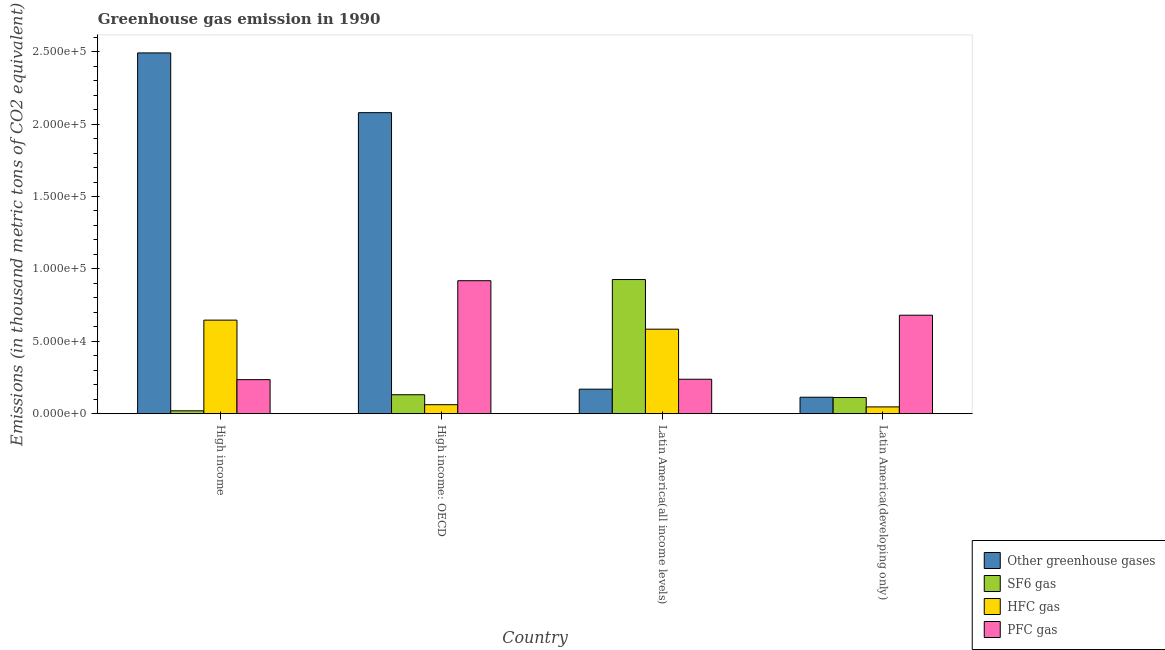How many different coloured bars are there?
Ensure brevity in your answer.  4. How many groups of bars are there?
Provide a succinct answer. 4. Are the number of bars on each tick of the X-axis equal?
Your response must be concise. Yes. How many bars are there on the 2nd tick from the left?
Your answer should be compact. 4. How many bars are there on the 1st tick from the right?
Offer a terse response. 4. What is the label of the 2nd group of bars from the left?
Ensure brevity in your answer.  High income: OECD. What is the emission of sf6 gas in Latin America(developing only)?
Your answer should be very brief. 1.12e+04. Across all countries, what is the maximum emission of hfc gas?
Give a very brief answer. 6.46e+04. Across all countries, what is the minimum emission of pfc gas?
Ensure brevity in your answer.  2.35e+04. In which country was the emission of hfc gas minimum?
Provide a succinct answer. Latin America(developing only). What is the total emission of sf6 gas in the graph?
Your answer should be very brief. 1.19e+05. What is the difference between the emission of hfc gas in High income and that in Latin America(all income levels)?
Your answer should be very brief. 6246.3. What is the difference between the emission of pfc gas in Latin America(all income levels) and the emission of sf6 gas in Latin America(developing only)?
Make the answer very short. 1.26e+04. What is the average emission of greenhouse gases per country?
Your response must be concise. 1.21e+05. What is the difference between the emission of hfc gas and emission of sf6 gas in Latin America(developing only)?
Your response must be concise. -6470.2. In how many countries, is the emission of hfc gas greater than 30000 thousand metric tons?
Make the answer very short. 2. What is the ratio of the emission of sf6 gas in Latin America(all income levels) to that in Latin America(developing only)?
Give a very brief answer. 8.28. Is the emission of greenhouse gases in High income less than that in Latin America(developing only)?
Give a very brief answer. No. What is the difference between the highest and the second highest emission of pfc gas?
Offer a very short reply. 2.38e+04. What is the difference between the highest and the lowest emission of sf6 gas?
Provide a short and direct response. 9.06e+04. Is the sum of the emission of pfc gas in Latin America(all income levels) and Latin America(developing only) greater than the maximum emission of hfc gas across all countries?
Make the answer very short. Yes. What does the 3rd bar from the left in High income: OECD represents?
Provide a short and direct response. HFC gas. What does the 2nd bar from the right in Latin America(developing only) represents?
Your response must be concise. HFC gas. Is it the case that in every country, the sum of the emission of greenhouse gases and emission of sf6 gas is greater than the emission of hfc gas?
Make the answer very short. Yes. Are all the bars in the graph horizontal?
Provide a succinct answer. No. How many countries are there in the graph?
Give a very brief answer. 4. Are the values on the major ticks of Y-axis written in scientific E-notation?
Keep it short and to the point. Yes. Does the graph contain any zero values?
Give a very brief answer. No. Where does the legend appear in the graph?
Your response must be concise. Bottom right. How many legend labels are there?
Offer a very short reply. 4. How are the legend labels stacked?
Keep it short and to the point. Vertical. What is the title of the graph?
Your answer should be very brief. Greenhouse gas emission in 1990. Does "Environmental sustainability" appear as one of the legend labels in the graph?
Offer a terse response. No. What is the label or title of the X-axis?
Provide a short and direct response. Country. What is the label or title of the Y-axis?
Provide a short and direct response. Emissions (in thousand metric tons of CO2 equivalent). What is the Emissions (in thousand metric tons of CO2 equivalent) of Other greenhouse gases in High income?
Provide a succinct answer. 2.49e+05. What is the Emissions (in thousand metric tons of CO2 equivalent) in SF6 gas in High income?
Offer a very short reply. 2028.7. What is the Emissions (in thousand metric tons of CO2 equivalent) in HFC gas in High income?
Make the answer very short. 6.46e+04. What is the Emissions (in thousand metric tons of CO2 equivalent) in PFC gas in High income?
Make the answer very short. 2.35e+04. What is the Emissions (in thousand metric tons of CO2 equivalent) of Other greenhouse gases in High income: OECD?
Ensure brevity in your answer.  2.08e+05. What is the Emissions (in thousand metric tons of CO2 equivalent) in SF6 gas in High income: OECD?
Provide a short and direct response. 1.31e+04. What is the Emissions (in thousand metric tons of CO2 equivalent) in HFC gas in High income: OECD?
Keep it short and to the point. 6246.3. What is the Emissions (in thousand metric tons of CO2 equivalent) of PFC gas in High income: OECD?
Your answer should be very brief. 9.19e+04. What is the Emissions (in thousand metric tons of CO2 equivalent) of Other greenhouse gases in Latin America(all income levels)?
Your answer should be compact. 1.70e+04. What is the Emissions (in thousand metric tons of CO2 equivalent) in SF6 gas in Latin America(all income levels)?
Offer a very short reply. 9.27e+04. What is the Emissions (in thousand metric tons of CO2 equivalent) of HFC gas in Latin America(all income levels)?
Offer a terse response. 5.84e+04. What is the Emissions (in thousand metric tons of CO2 equivalent) in PFC gas in Latin America(all income levels)?
Provide a succinct answer. 2.38e+04. What is the Emissions (in thousand metric tons of CO2 equivalent) in Other greenhouse gases in Latin America(developing only)?
Ensure brevity in your answer.  1.14e+04. What is the Emissions (in thousand metric tons of CO2 equivalent) in SF6 gas in Latin America(developing only)?
Provide a short and direct response. 1.12e+04. What is the Emissions (in thousand metric tons of CO2 equivalent) in HFC gas in Latin America(developing only)?
Give a very brief answer. 4722. What is the Emissions (in thousand metric tons of CO2 equivalent) of PFC gas in Latin America(developing only)?
Make the answer very short. 6.80e+04. Across all countries, what is the maximum Emissions (in thousand metric tons of CO2 equivalent) of Other greenhouse gases?
Offer a very short reply. 2.49e+05. Across all countries, what is the maximum Emissions (in thousand metric tons of CO2 equivalent) of SF6 gas?
Offer a very short reply. 9.27e+04. Across all countries, what is the maximum Emissions (in thousand metric tons of CO2 equivalent) of HFC gas?
Provide a short and direct response. 6.46e+04. Across all countries, what is the maximum Emissions (in thousand metric tons of CO2 equivalent) in PFC gas?
Your answer should be very brief. 9.19e+04. Across all countries, what is the minimum Emissions (in thousand metric tons of CO2 equivalent) in Other greenhouse gases?
Your answer should be very brief. 1.14e+04. Across all countries, what is the minimum Emissions (in thousand metric tons of CO2 equivalent) in SF6 gas?
Make the answer very short. 2028.7. Across all countries, what is the minimum Emissions (in thousand metric tons of CO2 equivalent) of HFC gas?
Make the answer very short. 4722. Across all countries, what is the minimum Emissions (in thousand metric tons of CO2 equivalent) of PFC gas?
Your answer should be compact. 2.35e+04. What is the total Emissions (in thousand metric tons of CO2 equivalent) of Other greenhouse gases in the graph?
Your answer should be compact. 4.85e+05. What is the total Emissions (in thousand metric tons of CO2 equivalent) in SF6 gas in the graph?
Offer a terse response. 1.19e+05. What is the total Emissions (in thousand metric tons of CO2 equivalent) in HFC gas in the graph?
Offer a terse response. 1.34e+05. What is the total Emissions (in thousand metric tons of CO2 equivalent) of PFC gas in the graph?
Your answer should be very brief. 2.07e+05. What is the difference between the Emissions (in thousand metric tons of CO2 equivalent) in Other greenhouse gases in High income and that in High income: OECD?
Your answer should be very brief. 4.13e+04. What is the difference between the Emissions (in thousand metric tons of CO2 equivalent) in SF6 gas in High income and that in High income: OECD?
Make the answer very short. -1.11e+04. What is the difference between the Emissions (in thousand metric tons of CO2 equivalent) in HFC gas in High income and that in High income: OECD?
Your response must be concise. 5.84e+04. What is the difference between the Emissions (in thousand metric tons of CO2 equivalent) of PFC gas in High income and that in High income: OECD?
Offer a very short reply. -6.83e+04. What is the difference between the Emissions (in thousand metric tons of CO2 equivalent) in Other greenhouse gases in High income and that in Latin America(all income levels)?
Provide a succinct answer. 2.32e+05. What is the difference between the Emissions (in thousand metric tons of CO2 equivalent) of SF6 gas in High income and that in Latin America(all income levels)?
Provide a succinct answer. -9.06e+04. What is the difference between the Emissions (in thousand metric tons of CO2 equivalent) of HFC gas in High income and that in Latin America(all income levels)?
Offer a very short reply. 6246.3. What is the difference between the Emissions (in thousand metric tons of CO2 equivalent) in PFC gas in High income and that in Latin America(all income levels)?
Your answer should be compact. -283.1. What is the difference between the Emissions (in thousand metric tons of CO2 equivalent) in Other greenhouse gases in High income and that in Latin America(developing only)?
Offer a very short reply. 2.38e+05. What is the difference between the Emissions (in thousand metric tons of CO2 equivalent) of SF6 gas in High income and that in Latin America(developing only)?
Provide a short and direct response. -9163.5. What is the difference between the Emissions (in thousand metric tons of CO2 equivalent) in HFC gas in High income and that in Latin America(developing only)?
Your answer should be compact. 5.99e+04. What is the difference between the Emissions (in thousand metric tons of CO2 equivalent) of PFC gas in High income and that in Latin America(developing only)?
Provide a short and direct response. -4.45e+04. What is the difference between the Emissions (in thousand metric tons of CO2 equivalent) of Other greenhouse gases in High income: OECD and that in Latin America(all income levels)?
Make the answer very short. 1.91e+05. What is the difference between the Emissions (in thousand metric tons of CO2 equivalent) of SF6 gas in High income: OECD and that in Latin America(all income levels)?
Ensure brevity in your answer.  -7.95e+04. What is the difference between the Emissions (in thousand metric tons of CO2 equivalent) of HFC gas in High income: OECD and that in Latin America(all income levels)?
Your answer should be compact. -5.21e+04. What is the difference between the Emissions (in thousand metric tons of CO2 equivalent) in PFC gas in High income: OECD and that in Latin America(all income levels)?
Provide a succinct answer. 6.80e+04. What is the difference between the Emissions (in thousand metric tons of CO2 equivalent) in Other greenhouse gases in High income: OECD and that in Latin America(developing only)?
Offer a very short reply. 1.96e+05. What is the difference between the Emissions (in thousand metric tons of CO2 equivalent) of SF6 gas in High income: OECD and that in Latin America(developing only)?
Ensure brevity in your answer.  1924.3. What is the difference between the Emissions (in thousand metric tons of CO2 equivalent) of HFC gas in High income: OECD and that in Latin America(developing only)?
Offer a very short reply. 1524.3. What is the difference between the Emissions (in thousand metric tons of CO2 equivalent) of PFC gas in High income: OECD and that in Latin America(developing only)?
Give a very brief answer. 2.38e+04. What is the difference between the Emissions (in thousand metric tons of CO2 equivalent) of Other greenhouse gases in Latin America(all income levels) and that in Latin America(developing only)?
Give a very brief answer. 5561.3. What is the difference between the Emissions (in thousand metric tons of CO2 equivalent) of SF6 gas in Latin America(all income levels) and that in Latin America(developing only)?
Your answer should be very brief. 8.15e+04. What is the difference between the Emissions (in thousand metric tons of CO2 equivalent) in HFC gas in Latin America(all income levels) and that in Latin America(developing only)?
Keep it short and to the point. 5.37e+04. What is the difference between the Emissions (in thousand metric tons of CO2 equivalent) in PFC gas in Latin America(all income levels) and that in Latin America(developing only)?
Ensure brevity in your answer.  -4.42e+04. What is the difference between the Emissions (in thousand metric tons of CO2 equivalent) of Other greenhouse gases in High income and the Emissions (in thousand metric tons of CO2 equivalent) of SF6 gas in High income: OECD?
Your answer should be very brief. 2.36e+05. What is the difference between the Emissions (in thousand metric tons of CO2 equivalent) in Other greenhouse gases in High income and the Emissions (in thousand metric tons of CO2 equivalent) in HFC gas in High income: OECD?
Ensure brevity in your answer.  2.43e+05. What is the difference between the Emissions (in thousand metric tons of CO2 equivalent) of Other greenhouse gases in High income and the Emissions (in thousand metric tons of CO2 equivalent) of PFC gas in High income: OECD?
Ensure brevity in your answer.  1.57e+05. What is the difference between the Emissions (in thousand metric tons of CO2 equivalent) of SF6 gas in High income and the Emissions (in thousand metric tons of CO2 equivalent) of HFC gas in High income: OECD?
Keep it short and to the point. -4217.6. What is the difference between the Emissions (in thousand metric tons of CO2 equivalent) of SF6 gas in High income and the Emissions (in thousand metric tons of CO2 equivalent) of PFC gas in High income: OECD?
Your answer should be compact. -8.98e+04. What is the difference between the Emissions (in thousand metric tons of CO2 equivalent) of HFC gas in High income and the Emissions (in thousand metric tons of CO2 equivalent) of PFC gas in High income: OECD?
Ensure brevity in your answer.  -2.72e+04. What is the difference between the Emissions (in thousand metric tons of CO2 equivalent) of Other greenhouse gases in High income and the Emissions (in thousand metric tons of CO2 equivalent) of SF6 gas in Latin America(all income levels)?
Provide a succinct answer. 1.56e+05. What is the difference between the Emissions (in thousand metric tons of CO2 equivalent) of Other greenhouse gases in High income and the Emissions (in thousand metric tons of CO2 equivalent) of HFC gas in Latin America(all income levels)?
Make the answer very short. 1.91e+05. What is the difference between the Emissions (in thousand metric tons of CO2 equivalent) in Other greenhouse gases in High income and the Emissions (in thousand metric tons of CO2 equivalent) in PFC gas in Latin America(all income levels)?
Provide a short and direct response. 2.25e+05. What is the difference between the Emissions (in thousand metric tons of CO2 equivalent) in SF6 gas in High income and the Emissions (in thousand metric tons of CO2 equivalent) in HFC gas in Latin America(all income levels)?
Ensure brevity in your answer.  -5.64e+04. What is the difference between the Emissions (in thousand metric tons of CO2 equivalent) of SF6 gas in High income and the Emissions (in thousand metric tons of CO2 equivalent) of PFC gas in Latin America(all income levels)?
Keep it short and to the point. -2.18e+04. What is the difference between the Emissions (in thousand metric tons of CO2 equivalent) in HFC gas in High income and the Emissions (in thousand metric tons of CO2 equivalent) in PFC gas in Latin America(all income levels)?
Keep it short and to the point. 4.08e+04. What is the difference between the Emissions (in thousand metric tons of CO2 equivalent) in Other greenhouse gases in High income and the Emissions (in thousand metric tons of CO2 equivalent) in SF6 gas in Latin America(developing only)?
Provide a short and direct response. 2.38e+05. What is the difference between the Emissions (in thousand metric tons of CO2 equivalent) of Other greenhouse gases in High income and the Emissions (in thousand metric tons of CO2 equivalent) of HFC gas in Latin America(developing only)?
Your response must be concise. 2.44e+05. What is the difference between the Emissions (in thousand metric tons of CO2 equivalent) of Other greenhouse gases in High income and the Emissions (in thousand metric tons of CO2 equivalent) of PFC gas in Latin America(developing only)?
Provide a short and direct response. 1.81e+05. What is the difference between the Emissions (in thousand metric tons of CO2 equivalent) in SF6 gas in High income and the Emissions (in thousand metric tons of CO2 equivalent) in HFC gas in Latin America(developing only)?
Offer a terse response. -2693.3. What is the difference between the Emissions (in thousand metric tons of CO2 equivalent) in SF6 gas in High income and the Emissions (in thousand metric tons of CO2 equivalent) in PFC gas in Latin America(developing only)?
Offer a terse response. -6.60e+04. What is the difference between the Emissions (in thousand metric tons of CO2 equivalent) of HFC gas in High income and the Emissions (in thousand metric tons of CO2 equivalent) of PFC gas in Latin America(developing only)?
Make the answer very short. -3401.8. What is the difference between the Emissions (in thousand metric tons of CO2 equivalent) in Other greenhouse gases in High income: OECD and the Emissions (in thousand metric tons of CO2 equivalent) in SF6 gas in Latin America(all income levels)?
Give a very brief answer. 1.15e+05. What is the difference between the Emissions (in thousand metric tons of CO2 equivalent) of Other greenhouse gases in High income: OECD and the Emissions (in thousand metric tons of CO2 equivalent) of HFC gas in Latin America(all income levels)?
Your response must be concise. 1.50e+05. What is the difference between the Emissions (in thousand metric tons of CO2 equivalent) of Other greenhouse gases in High income: OECD and the Emissions (in thousand metric tons of CO2 equivalent) of PFC gas in Latin America(all income levels)?
Give a very brief answer. 1.84e+05. What is the difference between the Emissions (in thousand metric tons of CO2 equivalent) in SF6 gas in High income: OECD and the Emissions (in thousand metric tons of CO2 equivalent) in HFC gas in Latin America(all income levels)?
Keep it short and to the point. -4.53e+04. What is the difference between the Emissions (in thousand metric tons of CO2 equivalent) of SF6 gas in High income: OECD and the Emissions (in thousand metric tons of CO2 equivalent) of PFC gas in Latin America(all income levels)?
Offer a very short reply. -1.07e+04. What is the difference between the Emissions (in thousand metric tons of CO2 equivalent) in HFC gas in High income: OECD and the Emissions (in thousand metric tons of CO2 equivalent) in PFC gas in Latin America(all income levels)?
Your answer should be very brief. -1.76e+04. What is the difference between the Emissions (in thousand metric tons of CO2 equivalent) in Other greenhouse gases in High income: OECD and the Emissions (in thousand metric tons of CO2 equivalent) in SF6 gas in Latin America(developing only)?
Provide a short and direct response. 1.97e+05. What is the difference between the Emissions (in thousand metric tons of CO2 equivalent) in Other greenhouse gases in High income: OECD and the Emissions (in thousand metric tons of CO2 equivalent) in HFC gas in Latin America(developing only)?
Provide a short and direct response. 2.03e+05. What is the difference between the Emissions (in thousand metric tons of CO2 equivalent) of Other greenhouse gases in High income: OECD and the Emissions (in thousand metric tons of CO2 equivalent) of PFC gas in Latin America(developing only)?
Your answer should be very brief. 1.40e+05. What is the difference between the Emissions (in thousand metric tons of CO2 equivalent) in SF6 gas in High income: OECD and the Emissions (in thousand metric tons of CO2 equivalent) in HFC gas in Latin America(developing only)?
Offer a terse response. 8394.5. What is the difference between the Emissions (in thousand metric tons of CO2 equivalent) of SF6 gas in High income: OECD and the Emissions (in thousand metric tons of CO2 equivalent) of PFC gas in Latin America(developing only)?
Your response must be concise. -5.49e+04. What is the difference between the Emissions (in thousand metric tons of CO2 equivalent) of HFC gas in High income: OECD and the Emissions (in thousand metric tons of CO2 equivalent) of PFC gas in Latin America(developing only)?
Ensure brevity in your answer.  -6.18e+04. What is the difference between the Emissions (in thousand metric tons of CO2 equivalent) of Other greenhouse gases in Latin America(all income levels) and the Emissions (in thousand metric tons of CO2 equivalent) of SF6 gas in Latin America(developing only)?
Ensure brevity in your answer.  5773.6. What is the difference between the Emissions (in thousand metric tons of CO2 equivalent) in Other greenhouse gases in Latin America(all income levels) and the Emissions (in thousand metric tons of CO2 equivalent) in HFC gas in Latin America(developing only)?
Ensure brevity in your answer.  1.22e+04. What is the difference between the Emissions (in thousand metric tons of CO2 equivalent) in Other greenhouse gases in Latin America(all income levels) and the Emissions (in thousand metric tons of CO2 equivalent) in PFC gas in Latin America(developing only)?
Your answer should be compact. -5.11e+04. What is the difference between the Emissions (in thousand metric tons of CO2 equivalent) in SF6 gas in Latin America(all income levels) and the Emissions (in thousand metric tons of CO2 equivalent) in HFC gas in Latin America(developing only)?
Provide a succinct answer. 8.79e+04. What is the difference between the Emissions (in thousand metric tons of CO2 equivalent) in SF6 gas in Latin America(all income levels) and the Emissions (in thousand metric tons of CO2 equivalent) in PFC gas in Latin America(developing only)?
Give a very brief answer. 2.46e+04. What is the difference between the Emissions (in thousand metric tons of CO2 equivalent) in HFC gas in Latin America(all income levels) and the Emissions (in thousand metric tons of CO2 equivalent) in PFC gas in Latin America(developing only)?
Ensure brevity in your answer.  -9648.1. What is the average Emissions (in thousand metric tons of CO2 equivalent) of Other greenhouse gases per country?
Provide a succinct answer. 1.21e+05. What is the average Emissions (in thousand metric tons of CO2 equivalent) in SF6 gas per country?
Ensure brevity in your answer.  2.98e+04. What is the average Emissions (in thousand metric tons of CO2 equivalent) in HFC gas per country?
Your answer should be very brief. 3.35e+04. What is the average Emissions (in thousand metric tons of CO2 equivalent) in PFC gas per country?
Offer a very short reply. 5.18e+04. What is the difference between the Emissions (in thousand metric tons of CO2 equivalent) of Other greenhouse gases and Emissions (in thousand metric tons of CO2 equivalent) of SF6 gas in High income?
Provide a succinct answer. 2.47e+05. What is the difference between the Emissions (in thousand metric tons of CO2 equivalent) of Other greenhouse gases and Emissions (in thousand metric tons of CO2 equivalent) of HFC gas in High income?
Ensure brevity in your answer.  1.85e+05. What is the difference between the Emissions (in thousand metric tons of CO2 equivalent) in Other greenhouse gases and Emissions (in thousand metric tons of CO2 equivalent) in PFC gas in High income?
Provide a short and direct response. 2.26e+05. What is the difference between the Emissions (in thousand metric tons of CO2 equivalent) of SF6 gas and Emissions (in thousand metric tons of CO2 equivalent) of HFC gas in High income?
Provide a succinct answer. -6.26e+04. What is the difference between the Emissions (in thousand metric tons of CO2 equivalent) of SF6 gas and Emissions (in thousand metric tons of CO2 equivalent) of PFC gas in High income?
Provide a succinct answer. -2.15e+04. What is the difference between the Emissions (in thousand metric tons of CO2 equivalent) of HFC gas and Emissions (in thousand metric tons of CO2 equivalent) of PFC gas in High income?
Make the answer very short. 4.11e+04. What is the difference between the Emissions (in thousand metric tons of CO2 equivalent) of Other greenhouse gases and Emissions (in thousand metric tons of CO2 equivalent) of SF6 gas in High income: OECD?
Your answer should be very brief. 1.95e+05. What is the difference between the Emissions (in thousand metric tons of CO2 equivalent) of Other greenhouse gases and Emissions (in thousand metric tons of CO2 equivalent) of HFC gas in High income: OECD?
Your response must be concise. 2.02e+05. What is the difference between the Emissions (in thousand metric tons of CO2 equivalent) of Other greenhouse gases and Emissions (in thousand metric tons of CO2 equivalent) of PFC gas in High income: OECD?
Give a very brief answer. 1.16e+05. What is the difference between the Emissions (in thousand metric tons of CO2 equivalent) in SF6 gas and Emissions (in thousand metric tons of CO2 equivalent) in HFC gas in High income: OECD?
Give a very brief answer. 6870.2. What is the difference between the Emissions (in thousand metric tons of CO2 equivalent) of SF6 gas and Emissions (in thousand metric tons of CO2 equivalent) of PFC gas in High income: OECD?
Provide a succinct answer. -7.87e+04. What is the difference between the Emissions (in thousand metric tons of CO2 equivalent) in HFC gas and Emissions (in thousand metric tons of CO2 equivalent) in PFC gas in High income: OECD?
Make the answer very short. -8.56e+04. What is the difference between the Emissions (in thousand metric tons of CO2 equivalent) of Other greenhouse gases and Emissions (in thousand metric tons of CO2 equivalent) of SF6 gas in Latin America(all income levels)?
Keep it short and to the point. -7.57e+04. What is the difference between the Emissions (in thousand metric tons of CO2 equivalent) of Other greenhouse gases and Emissions (in thousand metric tons of CO2 equivalent) of HFC gas in Latin America(all income levels)?
Provide a short and direct response. -4.14e+04. What is the difference between the Emissions (in thousand metric tons of CO2 equivalent) of Other greenhouse gases and Emissions (in thousand metric tons of CO2 equivalent) of PFC gas in Latin America(all income levels)?
Provide a succinct answer. -6853.8. What is the difference between the Emissions (in thousand metric tons of CO2 equivalent) of SF6 gas and Emissions (in thousand metric tons of CO2 equivalent) of HFC gas in Latin America(all income levels)?
Ensure brevity in your answer.  3.43e+04. What is the difference between the Emissions (in thousand metric tons of CO2 equivalent) in SF6 gas and Emissions (in thousand metric tons of CO2 equivalent) in PFC gas in Latin America(all income levels)?
Offer a very short reply. 6.88e+04. What is the difference between the Emissions (in thousand metric tons of CO2 equivalent) in HFC gas and Emissions (in thousand metric tons of CO2 equivalent) in PFC gas in Latin America(all income levels)?
Offer a terse response. 3.46e+04. What is the difference between the Emissions (in thousand metric tons of CO2 equivalent) in Other greenhouse gases and Emissions (in thousand metric tons of CO2 equivalent) in SF6 gas in Latin America(developing only)?
Give a very brief answer. 212.3. What is the difference between the Emissions (in thousand metric tons of CO2 equivalent) in Other greenhouse gases and Emissions (in thousand metric tons of CO2 equivalent) in HFC gas in Latin America(developing only)?
Keep it short and to the point. 6682.5. What is the difference between the Emissions (in thousand metric tons of CO2 equivalent) in Other greenhouse gases and Emissions (in thousand metric tons of CO2 equivalent) in PFC gas in Latin America(developing only)?
Provide a short and direct response. -5.66e+04. What is the difference between the Emissions (in thousand metric tons of CO2 equivalent) of SF6 gas and Emissions (in thousand metric tons of CO2 equivalent) of HFC gas in Latin America(developing only)?
Ensure brevity in your answer.  6470.2. What is the difference between the Emissions (in thousand metric tons of CO2 equivalent) in SF6 gas and Emissions (in thousand metric tons of CO2 equivalent) in PFC gas in Latin America(developing only)?
Make the answer very short. -5.68e+04. What is the difference between the Emissions (in thousand metric tons of CO2 equivalent) of HFC gas and Emissions (in thousand metric tons of CO2 equivalent) of PFC gas in Latin America(developing only)?
Ensure brevity in your answer.  -6.33e+04. What is the ratio of the Emissions (in thousand metric tons of CO2 equivalent) in Other greenhouse gases in High income to that in High income: OECD?
Provide a succinct answer. 1.2. What is the ratio of the Emissions (in thousand metric tons of CO2 equivalent) in SF6 gas in High income to that in High income: OECD?
Offer a terse response. 0.15. What is the ratio of the Emissions (in thousand metric tons of CO2 equivalent) in HFC gas in High income to that in High income: OECD?
Offer a terse response. 10.35. What is the ratio of the Emissions (in thousand metric tons of CO2 equivalent) in PFC gas in High income to that in High income: OECD?
Provide a short and direct response. 0.26. What is the ratio of the Emissions (in thousand metric tons of CO2 equivalent) of Other greenhouse gases in High income to that in Latin America(all income levels)?
Keep it short and to the point. 14.69. What is the ratio of the Emissions (in thousand metric tons of CO2 equivalent) of SF6 gas in High income to that in Latin America(all income levels)?
Your answer should be compact. 0.02. What is the ratio of the Emissions (in thousand metric tons of CO2 equivalent) of HFC gas in High income to that in Latin America(all income levels)?
Give a very brief answer. 1.11. What is the ratio of the Emissions (in thousand metric tons of CO2 equivalent) of Other greenhouse gases in High income to that in Latin America(developing only)?
Provide a short and direct response. 21.85. What is the ratio of the Emissions (in thousand metric tons of CO2 equivalent) in SF6 gas in High income to that in Latin America(developing only)?
Your answer should be very brief. 0.18. What is the ratio of the Emissions (in thousand metric tons of CO2 equivalent) of HFC gas in High income to that in Latin America(developing only)?
Your answer should be compact. 13.69. What is the ratio of the Emissions (in thousand metric tons of CO2 equivalent) in PFC gas in High income to that in Latin America(developing only)?
Provide a short and direct response. 0.35. What is the ratio of the Emissions (in thousand metric tons of CO2 equivalent) in Other greenhouse gases in High income: OECD to that in Latin America(all income levels)?
Your answer should be compact. 12.25. What is the ratio of the Emissions (in thousand metric tons of CO2 equivalent) in SF6 gas in High income: OECD to that in Latin America(all income levels)?
Your answer should be very brief. 0.14. What is the ratio of the Emissions (in thousand metric tons of CO2 equivalent) of HFC gas in High income: OECD to that in Latin America(all income levels)?
Offer a terse response. 0.11. What is the ratio of the Emissions (in thousand metric tons of CO2 equivalent) in PFC gas in High income: OECD to that in Latin America(all income levels)?
Provide a succinct answer. 3.86. What is the ratio of the Emissions (in thousand metric tons of CO2 equivalent) of Other greenhouse gases in High income: OECD to that in Latin America(developing only)?
Offer a terse response. 18.23. What is the ratio of the Emissions (in thousand metric tons of CO2 equivalent) in SF6 gas in High income: OECD to that in Latin America(developing only)?
Give a very brief answer. 1.17. What is the ratio of the Emissions (in thousand metric tons of CO2 equivalent) in HFC gas in High income: OECD to that in Latin America(developing only)?
Your response must be concise. 1.32. What is the ratio of the Emissions (in thousand metric tons of CO2 equivalent) of PFC gas in High income: OECD to that in Latin America(developing only)?
Your response must be concise. 1.35. What is the ratio of the Emissions (in thousand metric tons of CO2 equivalent) in Other greenhouse gases in Latin America(all income levels) to that in Latin America(developing only)?
Your answer should be compact. 1.49. What is the ratio of the Emissions (in thousand metric tons of CO2 equivalent) of SF6 gas in Latin America(all income levels) to that in Latin America(developing only)?
Provide a short and direct response. 8.28. What is the ratio of the Emissions (in thousand metric tons of CO2 equivalent) of HFC gas in Latin America(all income levels) to that in Latin America(developing only)?
Provide a succinct answer. 12.37. What is the ratio of the Emissions (in thousand metric tons of CO2 equivalent) of PFC gas in Latin America(all income levels) to that in Latin America(developing only)?
Offer a terse response. 0.35. What is the difference between the highest and the second highest Emissions (in thousand metric tons of CO2 equivalent) of Other greenhouse gases?
Offer a terse response. 4.13e+04. What is the difference between the highest and the second highest Emissions (in thousand metric tons of CO2 equivalent) of SF6 gas?
Provide a short and direct response. 7.95e+04. What is the difference between the highest and the second highest Emissions (in thousand metric tons of CO2 equivalent) in HFC gas?
Your answer should be compact. 6246.3. What is the difference between the highest and the second highest Emissions (in thousand metric tons of CO2 equivalent) of PFC gas?
Keep it short and to the point. 2.38e+04. What is the difference between the highest and the lowest Emissions (in thousand metric tons of CO2 equivalent) of Other greenhouse gases?
Offer a very short reply. 2.38e+05. What is the difference between the highest and the lowest Emissions (in thousand metric tons of CO2 equivalent) in SF6 gas?
Your answer should be very brief. 9.06e+04. What is the difference between the highest and the lowest Emissions (in thousand metric tons of CO2 equivalent) in HFC gas?
Your answer should be very brief. 5.99e+04. What is the difference between the highest and the lowest Emissions (in thousand metric tons of CO2 equivalent) of PFC gas?
Make the answer very short. 6.83e+04. 